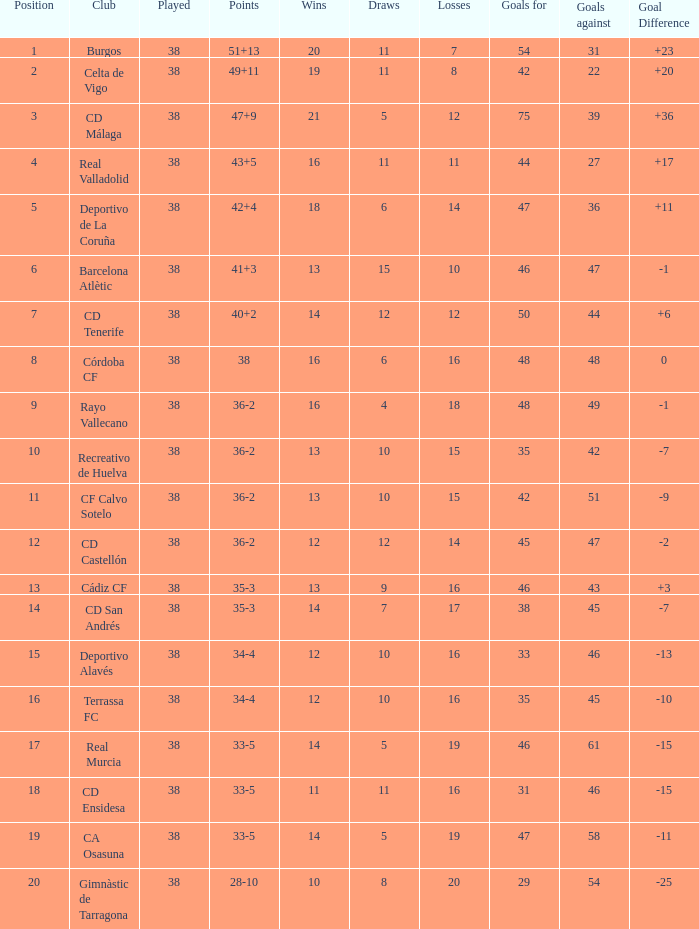What is the average loss with a goal higher than 51 and wins higher than 14? None. 